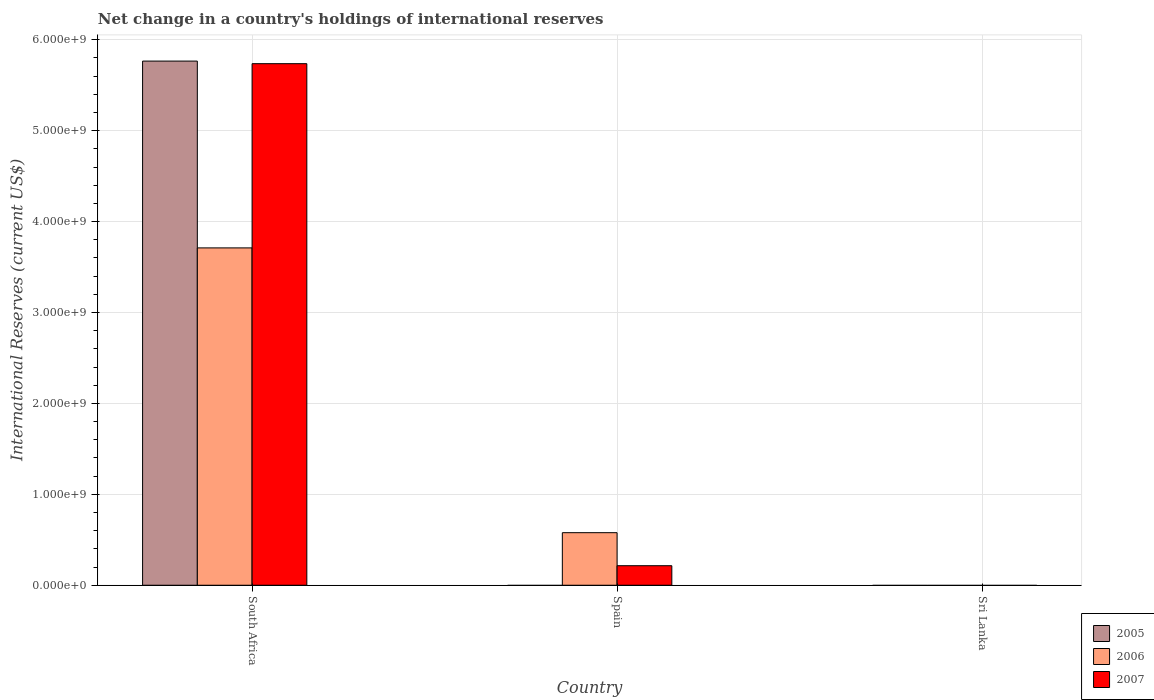Are the number of bars per tick equal to the number of legend labels?
Offer a terse response. No. How many bars are there on the 1st tick from the left?
Make the answer very short. 3. How many bars are there on the 2nd tick from the right?
Make the answer very short. 2. What is the label of the 3rd group of bars from the left?
Keep it short and to the point. Sri Lanka. In how many cases, is the number of bars for a given country not equal to the number of legend labels?
Provide a short and direct response. 2. What is the international reserves in 2005 in Spain?
Ensure brevity in your answer.  0. Across all countries, what is the maximum international reserves in 2007?
Offer a terse response. 5.74e+09. In which country was the international reserves in 2007 maximum?
Your answer should be compact. South Africa. What is the total international reserves in 2007 in the graph?
Give a very brief answer. 5.95e+09. What is the difference between the international reserves in 2007 in South Africa and that in Spain?
Make the answer very short. 5.52e+09. What is the difference between the international reserves in 2006 in Spain and the international reserves in 2007 in South Africa?
Keep it short and to the point. -5.16e+09. What is the average international reserves in 2007 per country?
Your answer should be very brief. 1.98e+09. What is the difference between the international reserves of/in 2007 and international reserves of/in 2006 in South Africa?
Your answer should be very brief. 2.03e+09. In how many countries, is the international reserves in 2007 greater than 3200000000 US$?
Provide a succinct answer. 1. What is the ratio of the international reserves in 2006 in South Africa to that in Spain?
Offer a very short reply. 6.42. Is the difference between the international reserves in 2007 in South Africa and Spain greater than the difference between the international reserves in 2006 in South Africa and Spain?
Make the answer very short. Yes. What is the difference between the highest and the lowest international reserves in 2006?
Your answer should be compact. 3.71e+09. Is it the case that in every country, the sum of the international reserves in 2005 and international reserves in 2007 is greater than the international reserves in 2006?
Provide a succinct answer. No. How many countries are there in the graph?
Keep it short and to the point. 3. How are the legend labels stacked?
Provide a succinct answer. Vertical. What is the title of the graph?
Offer a very short reply. Net change in a country's holdings of international reserves. What is the label or title of the Y-axis?
Offer a terse response. International Reserves (current US$). What is the International Reserves (current US$) of 2005 in South Africa?
Keep it short and to the point. 5.77e+09. What is the International Reserves (current US$) in 2006 in South Africa?
Provide a short and direct response. 3.71e+09. What is the International Reserves (current US$) in 2007 in South Africa?
Provide a succinct answer. 5.74e+09. What is the International Reserves (current US$) in 2005 in Spain?
Offer a terse response. 0. What is the International Reserves (current US$) of 2006 in Spain?
Your response must be concise. 5.78e+08. What is the International Reserves (current US$) of 2007 in Spain?
Offer a very short reply. 2.15e+08. What is the International Reserves (current US$) of 2006 in Sri Lanka?
Your answer should be compact. 0. What is the International Reserves (current US$) in 2007 in Sri Lanka?
Give a very brief answer. 0. Across all countries, what is the maximum International Reserves (current US$) in 2005?
Provide a short and direct response. 5.77e+09. Across all countries, what is the maximum International Reserves (current US$) in 2006?
Make the answer very short. 3.71e+09. Across all countries, what is the maximum International Reserves (current US$) in 2007?
Provide a succinct answer. 5.74e+09. Across all countries, what is the minimum International Reserves (current US$) of 2005?
Give a very brief answer. 0. Across all countries, what is the minimum International Reserves (current US$) of 2007?
Give a very brief answer. 0. What is the total International Reserves (current US$) in 2005 in the graph?
Your answer should be very brief. 5.77e+09. What is the total International Reserves (current US$) of 2006 in the graph?
Your response must be concise. 4.29e+09. What is the total International Reserves (current US$) in 2007 in the graph?
Provide a short and direct response. 5.95e+09. What is the difference between the International Reserves (current US$) in 2006 in South Africa and that in Spain?
Your answer should be very brief. 3.13e+09. What is the difference between the International Reserves (current US$) in 2007 in South Africa and that in Spain?
Ensure brevity in your answer.  5.52e+09. What is the difference between the International Reserves (current US$) in 2005 in South Africa and the International Reserves (current US$) in 2006 in Spain?
Offer a terse response. 5.19e+09. What is the difference between the International Reserves (current US$) of 2005 in South Africa and the International Reserves (current US$) of 2007 in Spain?
Give a very brief answer. 5.55e+09. What is the difference between the International Reserves (current US$) of 2006 in South Africa and the International Reserves (current US$) of 2007 in Spain?
Provide a short and direct response. 3.50e+09. What is the average International Reserves (current US$) of 2005 per country?
Provide a succinct answer. 1.92e+09. What is the average International Reserves (current US$) of 2006 per country?
Your response must be concise. 1.43e+09. What is the average International Reserves (current US$) in 2007 per country?
Your response must be concise. 1.98e+09. What is the difference between the International Reserves (current US$) of 2005 and International Reserves (current US$) of 2006 in South Africa?
Make the answer very short. 2.05e+09. What is the difference between the International Reserves (current US$) of 2005 and International Reserves (current US$) of 2007 in South Africa?
Offer a terse response. 2.86e+07. What is the difference between the International Reserves (current US$) of 2006 and International Reserves (current US$) of 2007 in South Africa?
Offer a terse response. -2.03e+09. What is the difference between the International Reserves (current US$) of 2006 and International Reserves (current US$) of 2007 in Spain?
Offer a terse response. 3.63e+08. What is the ratio of the International Reserves (current US$) of 2006 in South Africa to that in Spain?
Your answer should be very brief. 6.42. What is the ratio of the International Reserves (current US$) in 2007 in South Africa to that in Spain?
Provide a short and direct response. 26.7. What is the difference between the highest and the lowest International Reserves (current US$) in 2005?
Ensure brevity in your answer.  5.77e+09. What is the difference between the highest and the lowest International Reserves (current US$) of 2006?
Keep it short and to the point. 3.71e+09. What is the difference between the highest and the lowest International Reserves (current US$) in 2007?
Offer a terse response. 5.74e+09. 